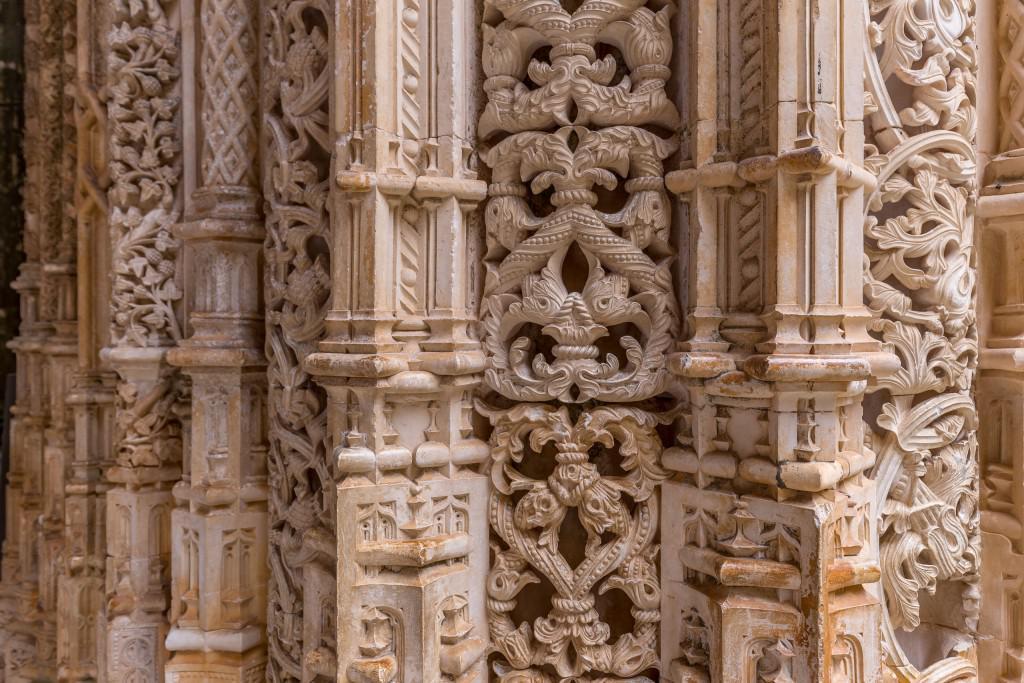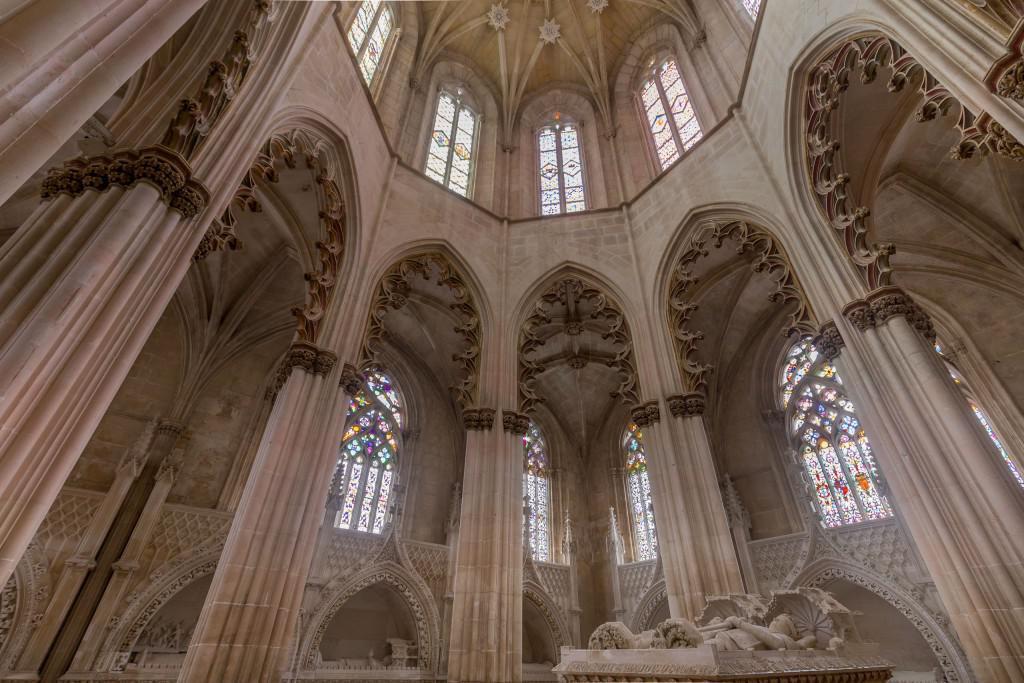The first image is the image on the left, the second image is the image on the right. For the images displayed, is the sentence "In at least one image there are one or more paintings." factually correct? Answer yes or no. No. The first image is the image on the left, the second image is the image on the right. Evaluate the accuracy of this statement regarding the images: "more then six arches can be seen in the left photo". Is it true? Answer yes or no. No. 